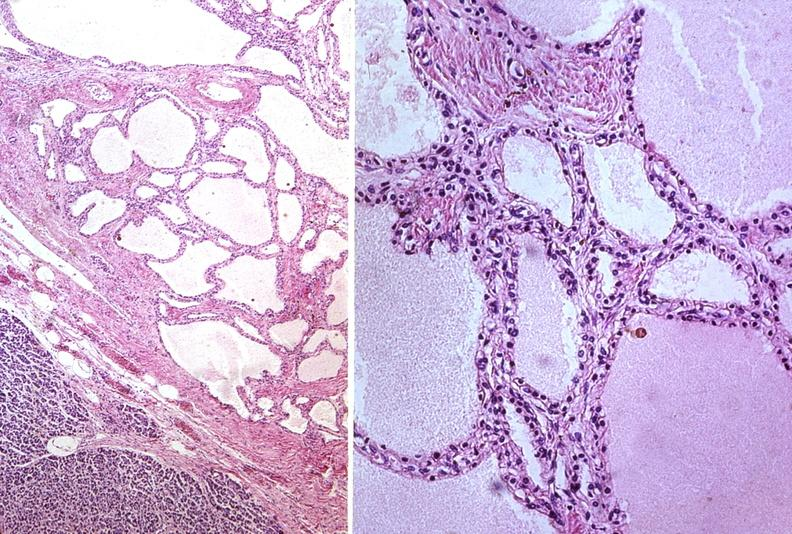what does this image show?
Answer the question using a single word or phrase. Cystadenoma 